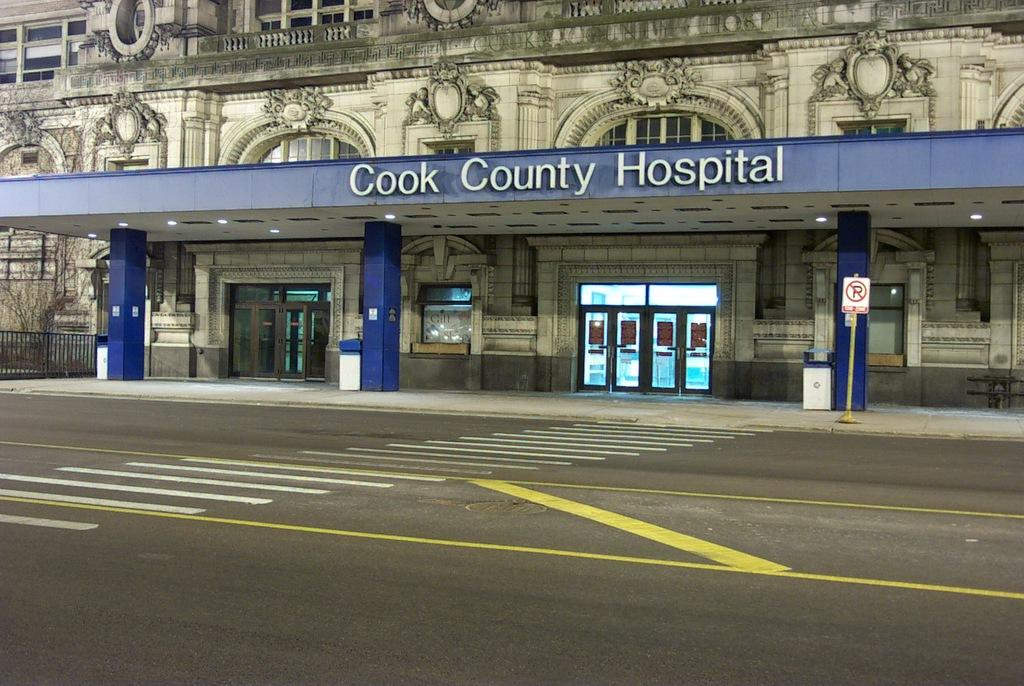<image>
Present a compact description of the photo's key features. The Cook County Hospital has a blue sign. 